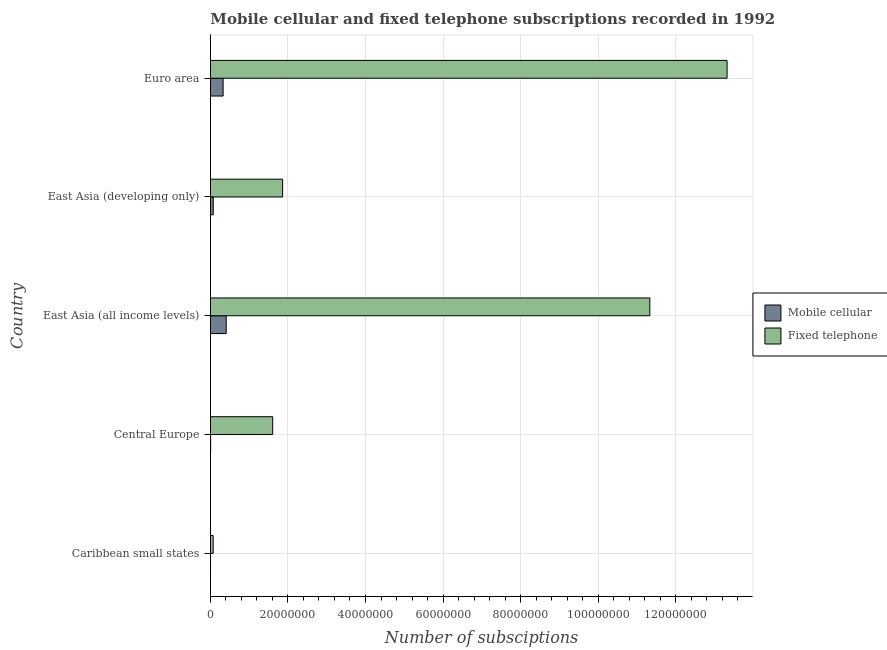How many groups of bars are there?
Ensure brevity in your answer.  5. Are the number of bars per tick equal to the number of legend labels?
Keep it short and to the point. Yes. How many bars are there on the 2nd tick from the top?
Ensure brevity in your answer.  2. How many bars are there on the 4th tick from the bottom?
Make the answer very short. 2. What is the label of the 2nd group of bars from the top?
Offer a terse response. East Asia (developing only). What is the number of fixed telephone subscriptions in East Asia (all income levels)?
Keep it short and to the point. 1.13e+08. Across all countries, what is the maximum number of fixed telephone subscriptions?
Make the answer very short. 1.33e+08. Across all countries, what is the minimum number of mobile cellular subscriptions?
Keep it short and to the point. 1.34e+04. In which country was the number of fixed telephone subscriptions maximum?
Offer a very short reply. Euro area. In which country was the number of mobile cellular subscriptions minimum?
Your answer should be very brief. Caribbean small states. What is the total number of fixed telephone subscriptions in the graph?
Offer a terse response. 2.82e+08. What is the difference between the number of mobile cellular subscriptions in Central Europe and that in Euro area?
Your response must be concise. -3.22e+06. What is the difference between the number of mobile cellular subscriptions in Central Europe and the number of fixed telephone subscriptions in Caribbean small states?
Ensure brevity in your answer.  -6.52e+05. What is the average number of mobile cellular subscriptions per country?
Keep it short and to the point. 1.62e+06. What is the difference between the number of mobile cellular subscriptions and number of fixed telephone subscriptions in Caribbean small states?
Give a very brief answer. -6.84e+05. What is the ratio of the number of fixed telephone subscriptions in Caribbean small states to that in Euro area?
Offer a terse response. 0.01. What is the difference between the highest and the second highest number of mobile cellular subscriptions?
Offer a very short reply. 7.95e+05. What is the difference between the highest and the lowest number of mobile cellular subscriptions?
Your answer should be compact. 4.04e+06. In how many countries, is the number of mobile cellular subscriptions greater than the average number of mobile cellular subscriptions taken over all countries?
Give a very brief answer. 2. Is the sum of the number of fixed telephone subscriptions in Caribbean small states and Central Europe greater than the maximum number of mobile cellular subscriptions across all countries?
Give a very brief answer. Yes. What does the 1st bar from the top in Caribbean small states represents?
Provide a short and direct response. Fixed telephone. What does the 2nd bar from the bottom in Caribbean small states represents?
Offer a terse response. Fixed telephone. Are all the bars in the graph horizontal?
Ensure brevity in your answer.  Yes. How many countries are there in the graph?
Your answer should be compact. 5. Are the values on the major ticks of X-axis written in scientific E-notation?
Ensure brevity in your answer.  No. Does the graph contain grids?
Ensure brevity in your answer.  Yes. Where does the legend appear in the graph?
Keep it short and to the point. Center right. How are the legend labels stacked?
Give a very brief answer. Vertical. What is the title of the graph?
Your response must be concise. Mobile cellular and fixed telephone subscriptions recorded in 1992. What is the label or title of the X-axis?
Provide a short and direct response. Number of subsciptions. What is the Number of subsciptions of Mobile cellular in Caribbean small states?
Your answer should be compact. 1.34e+04. What is the Number of subsciptions in Fixed telephone in Caribbean small states?
Offer a terse response. 6.97e+05. What is the Number of subsciptions in Mobile cellular in Central Europe?
Offer a terse response. 4.53e+04. What is the Number of subsciptions of Fixed telephone in Central Europe?
Your answer should be very brief. 1.61e+07. What is the Number of subsciptions in Mobile cellular in East Asia (all income levels)?
Ensure brevity in your answer.  4.06e+06. What is the Number of subsciptions in Fixed telephone in East Asia (all income levels)?
Provide a short and direct response. 1.13e+08. What is the Number of subsciptions of Mobile cellular in East Asia (developing only)?
Provide a short and direct response. 7.21e+05. What is the Number of subsciptions of Fixed telephone in East Asia (developing only)?
Your answer should be compact. 1.86e+07. What is the Number of subsciptions in Mobile cellular in Euro area?
Give a very brief answer. 3.26e+06. What is the Number of subsciptions of Fixed telephone in Euro area?
Your answer should be very brief. 1.33e+08. Across all countries, what is the maximum Number of subsciptions in Mobile cellular?
Provide a short and direct response. 4.06e+06. Across all countries, what is the maximum Number of subsciptions in Fixed telephone?
Give a very brief answer. 1.33e+08. Across all countries, what is the minimum Number of subsciptions of Mobile cellular?
Your answer should be compact. 1.34e+04. Across all countries, what is the minimum Number of subsciptions of Fixed telephone?
Your answer should be compact. 6.97e+05. What is the total Number of subsciptions of Mobile cellular in the graph?
Your answer should be very brief. 8.10e+06. What is the total Number of subsciptions of Fixed telephone in the graph?
Offer a terse response. 2.82e+08. What is the difference between the Number of subsciptions of Mobile cellular in Caribbean small states and that in Central Europe?
Provide a short and direct response. -3.19e+04. What is the difference between the Number of subsciptions in Fixed telephone in Caribbean small states and that in Central Europe?
Offer a very short reply. -1.54e+07. What is the difference between the Number of subsciptions of Mobile cellular in Caribbean small states and that in East Asia (all income levels)?
Your response must be concise. -4.04e+06. What is the difference between the Number of subsciptions in Fixed telephone in Caribbean small states and that in East Asia (all income levels)?
Keep it short and to the point. -1.13e+08. What is the difference between the Number of subsciptions in Mobile cellular in Caribbean small states and that in East Asia (developing only)?
Ensure brevity in your answer.  -7.08e+05. What is the difference between the Number of subsciptions in Fixed telephone in Caribbean small states and that in East Asia (developing only)?
Provide a succinct answer. -1.79e+07. What is the difference between the Number of subsciptions of Mobile cellular in Caribbean small states and that in Euro area?
Your answer should be very brief. -3.25e+06. What is the difference between the Number of subsciptions in Fixed telephone in Caribbean small states and that in Euro area?
Ensure brevity in your answer.  -1.33e+08. What is the difference between the Number of subsciptions of Mobile cellular in Central Europe and that in East Asia (all income levels)?
Your response must be concise. -4.01e+06. What is the difference between the Number of subsciptions in Fixed telephone in Central Europe and that in East Asia (all income levels)?
Give a very brief answer. -9.73e+07. What is the difference between the Number of subsciptions in Mobile cellular in Central Europe and that in East Asia (developing only)?
Your answer should be very brief. -6.76e+05. What is the difference between the Number of subsciptions of Fixed telephone in Central Europe and that in East Asia (developing only)?
Offer a very short reply. -2.56e+06. What is the difference between the Number of subsciptions of Mobile cellular in Central Europe and that in Euro area?
Offer a very short reply. -3.22e+06. What is the difference between the Number of subsciptions in Fixed telephone in Central Europe and that in Euro area?
Provide a succinct answer. -1.17e+08. What is the difference between the Number of subsciptions in Mobile cellular in East Asia (all income levels) and that in East Asia (developing only)?
Keep it short and to the point. 3.34e+06. What is the difference between the Number of subsciptions of Fixed telephone in East Asia (all income levels) and that in East Asia (developing only)?
Offer a very short reply. 9.48e+07. What is the difference between the Number of subsciptions in Mobile cellular in East Asia (all income levels) and that in Euro area?
Offer a terse response. 7.95e+05. What is the difference between the Number of subsciptions of Fixed telephone in East Asia (all income levels) and that in Euro area?
Offer a very short reply. -1.99e+07. What is the difference between the Number of subsciptions of Mobile cellular in East Asia (developing only) and that in Euro area?
Provide a short and direct response. -2.54e+06. What is the difference between the Number of subsciptions of Fixed telephone in East Asia (developing only) and that in Euro area?
Give a very brief answer. -1.15e+08. What is the difference between the Number of subsciptions in Mobile cellular in Caribbean small states and the Number of subsciptions in Fixed telephone in Central Europe?
Offer a terse response. -1.60e+07. What is the difference between the Number of subsciptions of Mobile cellular in Caribbean small states and the Number of subsciptions of Fixed telephone in East Asia (all income levels)?
Your answer should be compact. -1.13e+08. What is the difference between the Number of subsciptions of Mobile cellular in Caribbean small states and the Number of subsciptions of Fixed telephone in East Asia (developing only)?
Your answer should be very brief. -1.86e+07. What is the difference between the Number of subsciptions in Mobile cellular in Caribbean small states and the Number of subsciptions in Fixed telephone in Euro area?
Offer a very short reply. -1.33e+08. What is the difference between the Number of subsciptions of Mobile cellular in Central Europe and the Number of subsciptions of Fixed telephone in East Asia (all income levels)?
Offer a very short reply. -1.13e+08. What is the difference between the Number of subsciptions of Mobile cellular in Central Europe and the Number of subsciptions of Fixed telephone in East Asia (developing only)?
Give a very brief answer. -1.86e+07. What is the difference between the Number of subsciptions in Mobile cellular in Central Europe and the Number of subsciptions in Fixed telephone in Euro area?
Ensure brevity in your answer.  -1.33e+08. What is the difference between the Number of subsciptions in Mobile cellular in East Asia (all income levels) and the Number of subsciptions in Fixed telephone in East Asia (developing only)?
Offer a very short reply. -1.46e+07. What is the difference between the Number of subsciptions of Mobile cellular in East Asia (all income levels) and the Number of subsciptions of Fixed telephone in Euro area?
Ensure brevity in your answer.  -1.29e+08. What is the difference between the Number of subsciptions of Mobile cellular in East Asia (developing only) and the Number of subsciptions of Fixed telephone in Euro area?
Provide a short and direct response. -1.33e+08. What is the average Number of subsciptions of Mobile cellular per country?
Your answer should be very brief. 1.62e+06. What is the average Number of subsciptions of Fixed telephone per country?
Give a very brief answer. 5.64e+07. What is the difference between the Number of subsciptions in Mobile cellular and Number of subsciptions in Fixed telephone in Caribbean small states?
Provide a succinct answer. -6.84e+05. What is the difference between the Number of subsciptions in Mobile cellular and Number of subsciptions in Fixed telephone in Central Europe?
Ensure brevity in your answer.  -1.60e+07. What is the difference between the Number of subsciptions in Mobile cellular and Number of subsciptions in Fixed telephone in East Asia (all income levels)?
Offer a very short reply. -1.09e+08. What is the difference between the Number of subsciptions in Mobile cellular and Number of subsciptions in Fixed telephone in East Asia (developing only)?
Ensure brevity in your answer.  -1.79e+07. What is the difference between the Number of subsciptions of Mobile cellular and Number of subsciptions of Fixed telephone in Euro area?
Your response must be concise. -1.30e+08. What is the ratio of the Number of subsciptions of Mobile cellular in Caribbean small states to that in Central Europe?
Provide a succinct answer. 0.3. What is the ratio of the Number of subsciptions of Fixed telephone in Caribbean small states to that in Central Europe?
Provide a short and direct response. 0.04. What is the ratio of the Number of subsciptions in Mobile cellular in Caribbean small states to that in East Asia (all income levels)?
Provide a succinct answer. 0. What is the ratio of the Number of subsciptions of Fixed telephone in Caribbean small states to that in East Asia (all income levels)?
Make the answer very short. 0.01. What is the ratio of the Number of subsciptions of Mobile cellular in Caribbean small states to that in East Asia (developing only)?
Your answer should be compact. 0.02. What is the ratio of the Number of subsciptions in Fixed telephone in Caribbean small states to that in East Asia (developing only)?
Ensure brevity in your answer.  0.04. What is the ratio of the Number of subsciptions in Mobile cellular in Caribbean small states to that in Euro area?
Make the answer very short. 0. What is the ratio of the Number of subsciptions in Fixed telephone in Caribbean small states to that in Euro area?
Keep it short and to the point. 0.01. What is the ratio of the Number of subsciptions in Mobile cellular in Central Europe to that in East Asia (all income levels)?
Your answer should be compact. 0.01. What is the ratio of the Number of subsciptions of Fixed telephone in Central Europe to that in East Asia (all income levels)?
Provide a short and direct response. 0.14. What is the ratio of the Number of subsciptions in Mobile cellular in Central Europe to that in East Asia (developing only)?
Provide a short and direct response. 0.06. What is the ratio of the Number of subsciptions of Fixed telephone in Central Europe to that in East Asia (developing only)?
Provide a short and direct response. 0.86. What is the ratio of the Number of subsciptions in Mobile cellular in Central Europe to that in Euro area?
Your answer should be very brief. 0.01. What is the ratio of the Number of subsciptions in Fixed telephone in Central Europe to that in Euro area?
Give a very brief answer. 0.12. What is the ratio of the Number of subsciptions in Mobile cellular in East Asia (all income levels) to that in East Asia (developing only)?
Your answer should be compact. 5.62. What is the ratio of the Number of subsciptions of Fixed telephone in East Asia (all income levels) to that in East Asia (developing only)?
Keep it short and to the point. 6.09. What is the ratio of the Number of subsciptions in Mobile cellular in East Asia (all income levels) to that in Euro area?
Provide a succinct answer. 1.24. What is the ratio of the Number of subsciptions of Fixed telephone in East Asia (all income levels) to that in Euro area?
Your response must be concise. 0.85. What is the ratio of the Number of subsciptions of Mobile cellular in East Asia (developing only) to that in Euro area?
Ensure brevity in your answer.  0.22. What is the ratio of the Number of subsciptions of Fixed telephone in East Asia (developing only) to that in Euro area?
Make the answer very short. 0.14. What is the difference between the highest and the second highest Number of subsciptions in Mobile cellular?
Offer a terse response. 7.95e+05. What is the difference between the highest and the second highest Number of subsciptions in Fixed telephone?
Keep it short and to the point. 1.99e+07. What is the difference between the highest and the lowest Number of subsciptions in Mobile cellular?
Your response must be concise. 4.04e+06. What is the difference between the highest and the lowest Number of subsciptions in Fixed telephone?
Make the answer very short. 1.33e+08. 